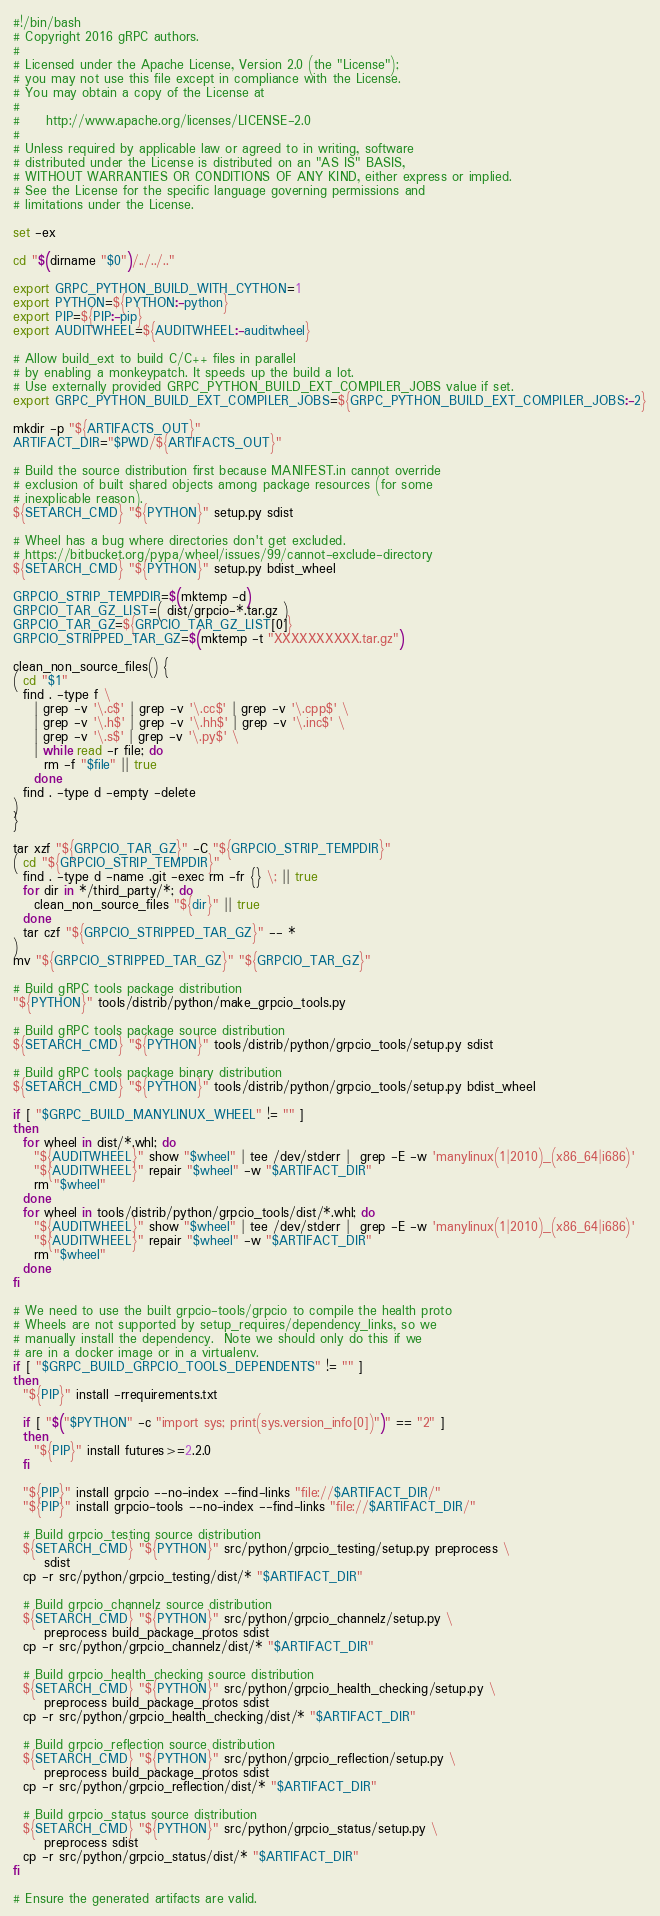Convert code to text. <code><loc_0><loc_0><loc_500><loc_500><_Bash_>#!/bin/bash
# Copyright 2016 gRPC authors.
#
# Licensed under the Apache License, Version 2.0 (the "License");
# you may not use this file except in compliance with the License.
# You may obtain a copy of the License at
#
#     http://www.apache.org/licenses/LICENSE-2.0
#
# Unless required by applicable law or agreed to in writing, software
# distributed under the License is distributed on an "AS IS" BASIS,
# WITHOUT WARRANTIES OR CONDITIONS OF ANY KIND, either express or implied.
# See the License for the specific language governing permissions and
# limitations under the License.

set -ex

cd "$(dirname "$0")/../../.."

export GRPC_PYTHON_BUILD_WITH_CYTHON=1
export PYTHON=${PYTHON:-python}
export PIP=${PIP:-pip}
export AUDITWHEEL=${AUDITWHEEL:-auditwheel}

# Allow build_ext to build C/C++ files in parallel
# by enabling a monkeypatch. It speeds up the build a lot.
# Use externally provided GRPC_PYTHON_BUILD_EXT_COMPILER_JOBS value if set.
export GRPC_PYTHON_BUILD_EXT_COMPILER_JOBS=${GRPC_PYTHON_BUILD_EXT_COMPILER_JOBS:-2}

mkdir -p "${ARTIFACTS_OUT}"
ARTIFACT_DIR="$PWD/${ARTIFACTS_OUT}"

# Build the source distribution first because MANIFEST.in cannot override
# exclusion of built shared objects among package resources (for some
# inexplicable reason).
${SETARCH_CMD} "${PYTHON}" setup.py sdist

# Wheel has a bug where directories don't get excluded.
# https://bitbucket.org/pypa/wheel/issues/99/cannot-exclude-directory
${SETARCH_CMD} "${PYTHON}" setup.py bdist_wheel

GRPCIO_STRIP_TEMPDIR=$(mktemp -d)
GRPCIO_TAR_GZ_LIST=( dist/grpcio-*.tar.gz )
GRPCIO_TAR_GZ=${GRPCIO_TAR_GZ_LIST[0]}
GRPCIO_STRIPPED_TAR_GZ=$(mktemp -t "XXXXXXXXXX.tar.gz")

clean_non_source_files() {
( cd "$1"
  find . -type f \
    | grep -v '\.c$' | grep -v '\.cc$' | grep -v '\.cpp$' \
    | grep -v '\.h$' | grep -v '\.hh$' | grep -v '\.inc$' \
    | grep -v '\.s$' | grep -v '\.py$' \
    | while read -r file; do
      rm -f "$file" || true
    done
  find . -type d -empty -delete
)
}

tar xzf "${GRPCIO_TAR_GZ}" -C "${GRPCIO_STRIP_TEMPDIR}"
( cd "${GRPCIO_STRIP_TEMPDIR}"
  find . -type d -name .git -exec rm -fr {} \; || true
  for dir in */third_party/*; do
    clean_non_source_files "${dir}" || true
  done
  tar czf "${GRPCIO_STRIPPED_TAR_GZ}" -- *
)
mv "${GRPCIO_STRIPPED_TAR_GZ}" "${GRPCIO_TAR_GZ}"

# Build gRPC tools package distribution
"${PYTHON}" tools/distrib/python/make_grpcio_tools.py

# Build gRPC tools package source distribution
${SETARCH_CMD} "${PYTHON}" tools/distrib/python/grpcio_tools/setup.py sdist

# Build gRPC tools package binary distribution
${SETARCH_CMD} "${PYTHON}" tools/distrib/python/grpcio_tools/setup.py bdist_wheel

if [ "$GRPC_BUILD_MANYLINUX_WHEEL" != "" ]
then
  for wheel in dist/*.whl; do
    "${AUDITWHEEL}" show "$wheel" | tee /dev/stderr |  grep -E -w 'manylinux(1|2010)_(x86_64|i686)'
    "${AUDITWHEEL}" repair "$wheel" -w "$ARTIFACT_DIR"
    rm "$wheel"
  done
  for wheel in tools/distrib/python/grpcio_tools/dist/*.whl; do
    "${AUDITWHEEL}" show "$wheel" | tee /dev/stderr |  grep -E -w 'manylinux(1|2010)_(x86_64|i686)'
    "${AUDITWHEEL}" repair "$wheel" -w "$ARTIFACT_DIR"
    rm "$wheel"
  done
fi

# We need to use the built grpcio-tools/grpcio to compile the health proto
# Wheels are not supported by setup_requires/dependency_links, so we
# manually install the dependency.  Note we should only do this if we
# are in a docker image or in a virtualenv.
if [ "$GRPC_BUILD_GRPCIO_TOOLS_DEPENDENTS" != "" ]
then
  "${PIP}" install -rrequirements.txt

  if [ "$("$PYTHON" -c "import sys; print(sys.version_info[0])")" == "2" ]
  then
    "${PIP}" install futures>=2.2.0
  fi

  "${PIP}" install grpcio --no-index --find-links "file://$ARTIFACT_DIR/"
  "${PIP}" install grpcio-tools --no-index --find-links "file://$ARTIFACT_DIR/"

  # Build grpcio_testing source distribution
  ${SETARCH_CMD} "${PYTHON}" src/python/grpcio_testing/setup.py preprocess \
      sdist
  cp -r src/python/grpcio_testing/dist/* "$ARTIFACT_DIR"

  # Build grpcio_channelz source distribution
  ${SETARCH_CMD} "${PYTHON}" src/python/grpcio_channelz/setup.py \
      preprocess build_package_protos sdist
  cp -r src/python/grpcio_channelz/dist/* "$ARTIFACT_DIR"

  # Build grpcio_health_checking source distribution
  ${SETARCH_CMD} "${PYTHON}" src/python/grpcio_health_checking/setup.py \
      preprocess build_package_protos sdist
  cp -r src/python/grpcio_health_checking/dist/* "$ARTIFACT_DIR"

  # Build grpcio_reflection source distribution
  ${SETARCH_CMD} "${PYTHON}" src/python/grpcio_reflection/setup.py \
      preprocess build_package_protos sdist
  cp -r src/python/grpcio_reflection/dist/* "$ARTIFACT_DIR"

  # Build grpcio_status source distribution
  ${SETARCH_CMD} "${PYTHON}" src/python/grpcio_status/setup.py \
      preprocess sdist
  cp -r src/python/grpcio_status/dist/* "$ARTIFACT_DIR"
fi

# Ensure the generated artifacts are valid.</code> 